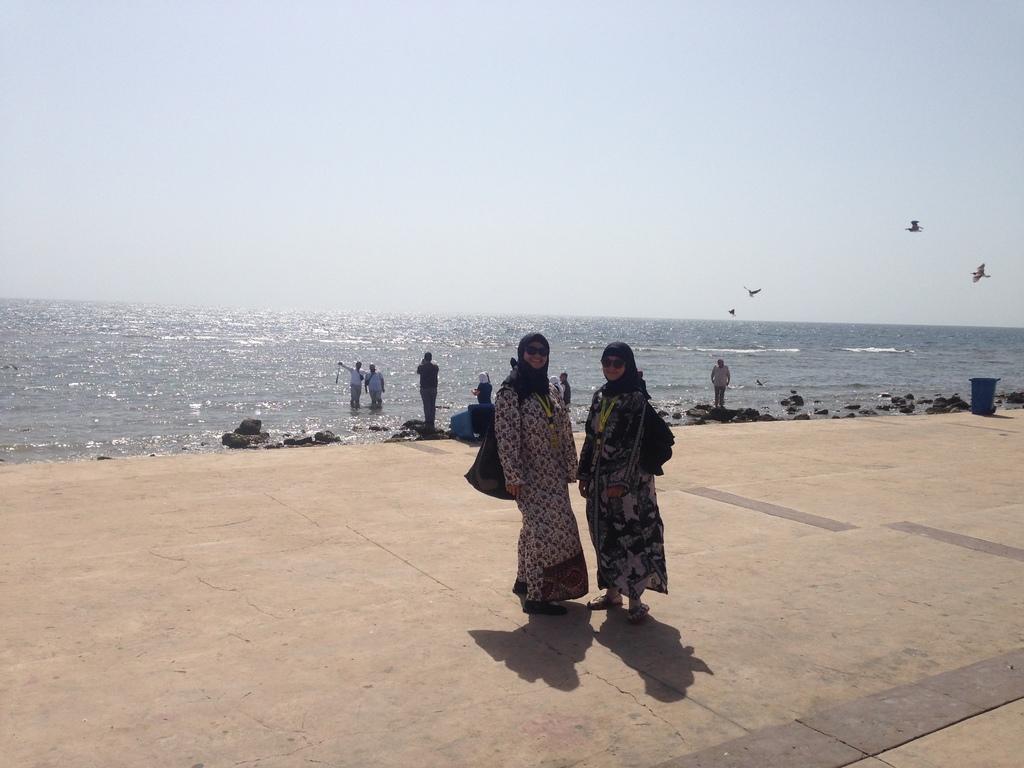How would you summarize this image in a sentence or two? In this image in the center there are two persons standing and they are wearing goggles and bags. In the background there is a beach and some persons are standing, and also i can see some rocks. At the top of the image there is sky and some birds are flying. At the bottom there is a walkway. 